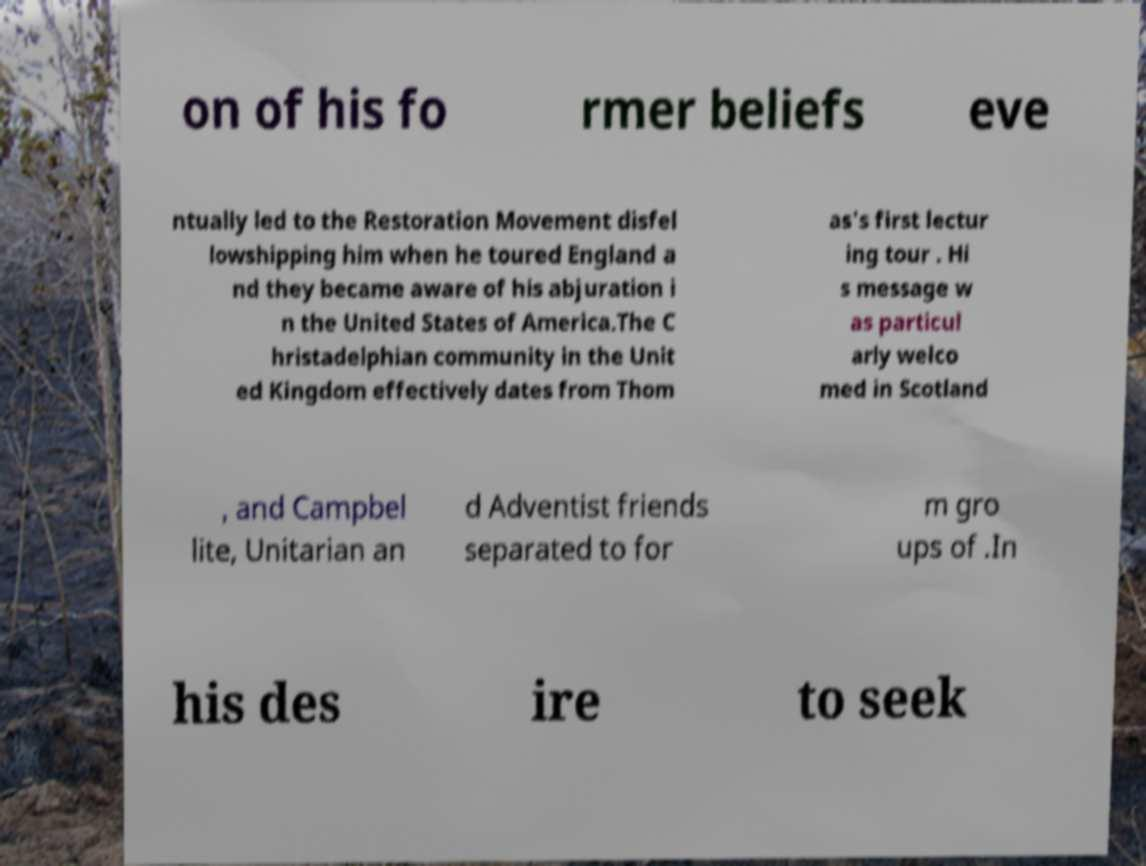Please read and relay the text visible in this image. What does it say? on of his fo rmer beliefs eve ntually led to the Restoration Movement disfel lowshipping him when he toured England a nd they became aware of his abjuration i n the United States of America.The C hristadelphian community in the Unit ed Kingdom effectively dates from Thom as's first lectur ing tour . Hi s message w as particul arly welco med in Scotland , and Campbel lite, Unitarian an d Adventist friends separated to for m gro ups of .In his des ire to seek 